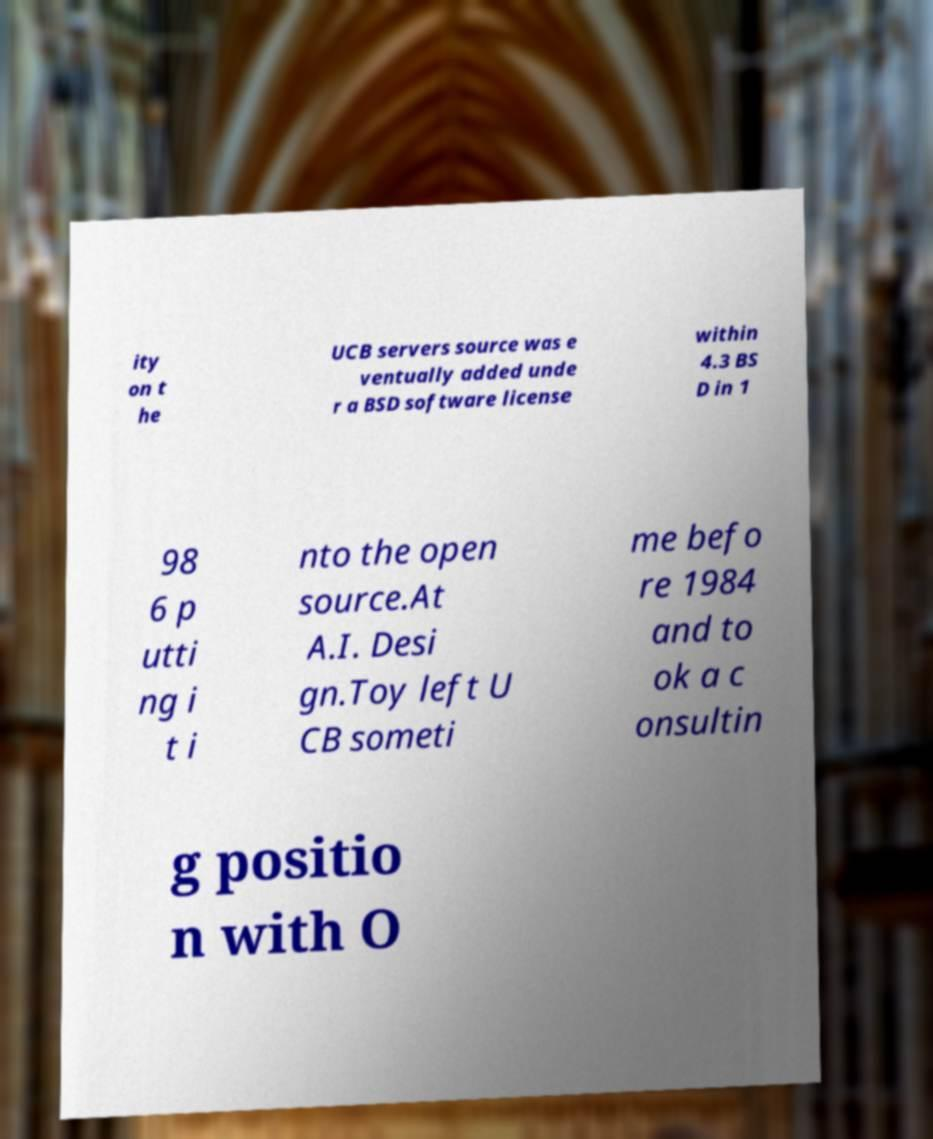Can you read and provide the text displayed in the image?This photo seems to have some interesting text. Can you extract and type it out for me? ity on t he UCB servers source was e ventually added unde r a BSD software license within 4.3 BS D in 1 98 6 p utti ng i t i nto the open source.At A.I. Desi gn.Toy left U CB someti me befo re 1984 and to ok a c onsultin g positio n with O 